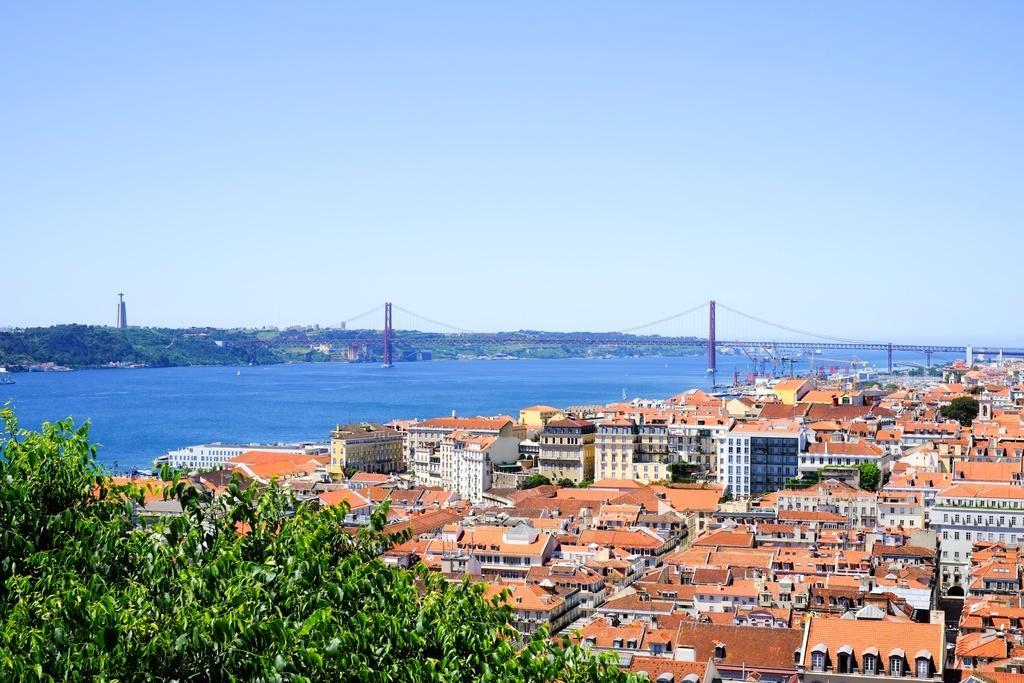In one or two sentences, can you explain what this image depicts? In this image in the front of there are leaves. In the background there are buildings and there is a sea and there is a bridge and there are trees. 